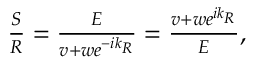Convert formula to latex. <formula><loc_0><loc_0><loc_500><loc_500>\begin{array} { r } { \frac { S } { R } = \frac { E } { v + w e ^ { - i k _ { R } } } = \frac { v + w e ^ { i k _ { R } } } { E } , } \end{array}</formula> 